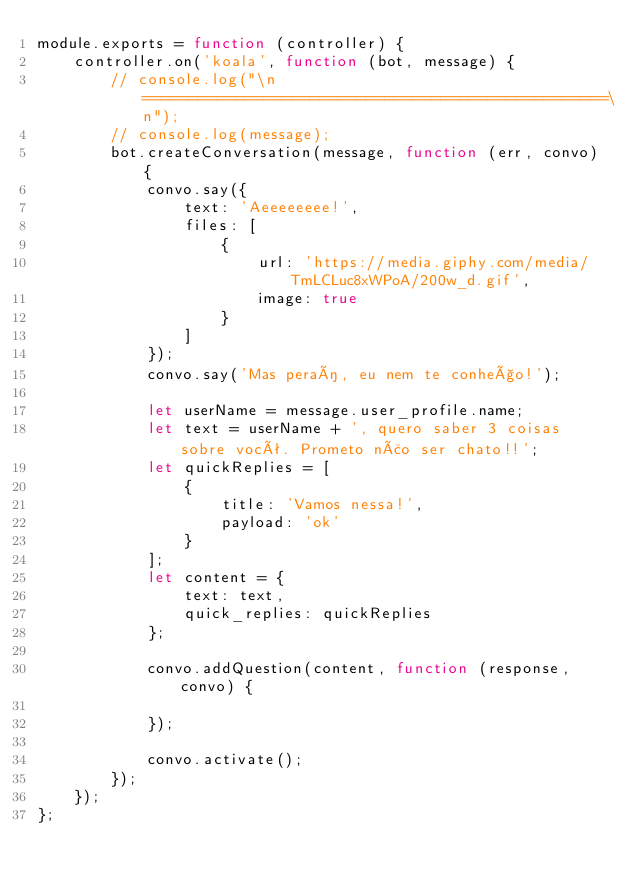Convert code to text. <code><loc_0><loc_0><loc_500><loc_500><_JavaScript_>module.exports = function (controller) {
    controller.on('koala', function (bot, message) {
        // console.log("\n==================================================\n");
        // console.log(message);
        bot.createConversation(message, function (err, convo) {
            convo.say({
                text: 'Aeeeeeeee!',
                files: [
                    {
                        url: 'https://media.giphy.com/media/TmLCLuc8xWPoA/200w_d.gif',
                        image: true
                    }
                ]
            });
            convo.say('Mas peraí, eu nem te conheço!');

            let userName = message.user_profile.name;
            let text = userName + ', quero saber 3 coisas sobre você. Prometo não ser chato!!';
            let quickReplies = [
                {
                    title: 'Vamos nessa!',
                    payload: 'ok'
                }
            ];
            let content = {
                text: text,
                quick_replies: quickReplies
            };
            
            convo.addQuestion(content, function (response, convo) {
                
            });

            convo.activate();
        });
    });
};</code> 